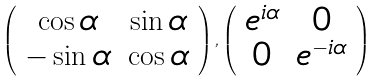Convert formula to latex. <formula><loc_0><loc_0><loc_500><loc_500>\left ( \begin{array} { c c } \cos \alpha & \sin \alpha \\ - \sin \alpha & \cos \alpha \end{array} \right ) , \left ( \begin{array} { c c } e ^ { i \alpha } & 0 \\ 0 & e ^ { - i \alpha } \end{array} \right )</formula> 